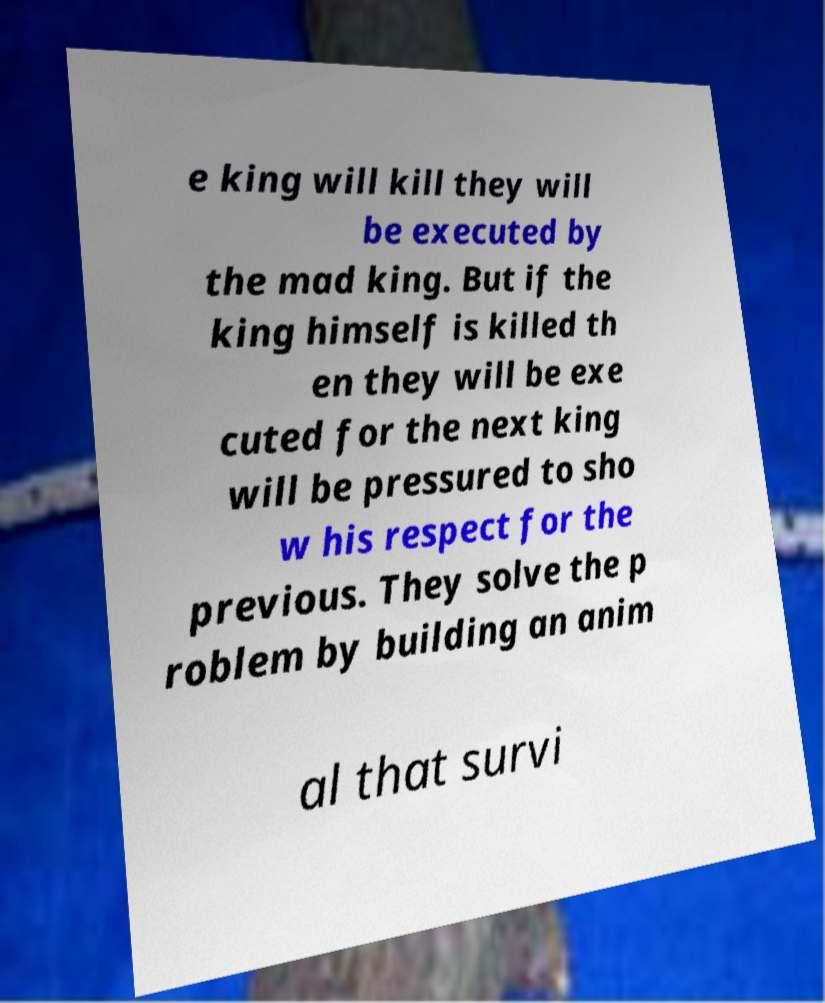Please read and relay the text visible in this image. What does it say? e king will kill they will be executed by the mad king. But if the king himself is killed th en they will be exe cuted for the next king will be pressured to sho w his respect for the previous. They solve the p roblem by building an anim al that survi 